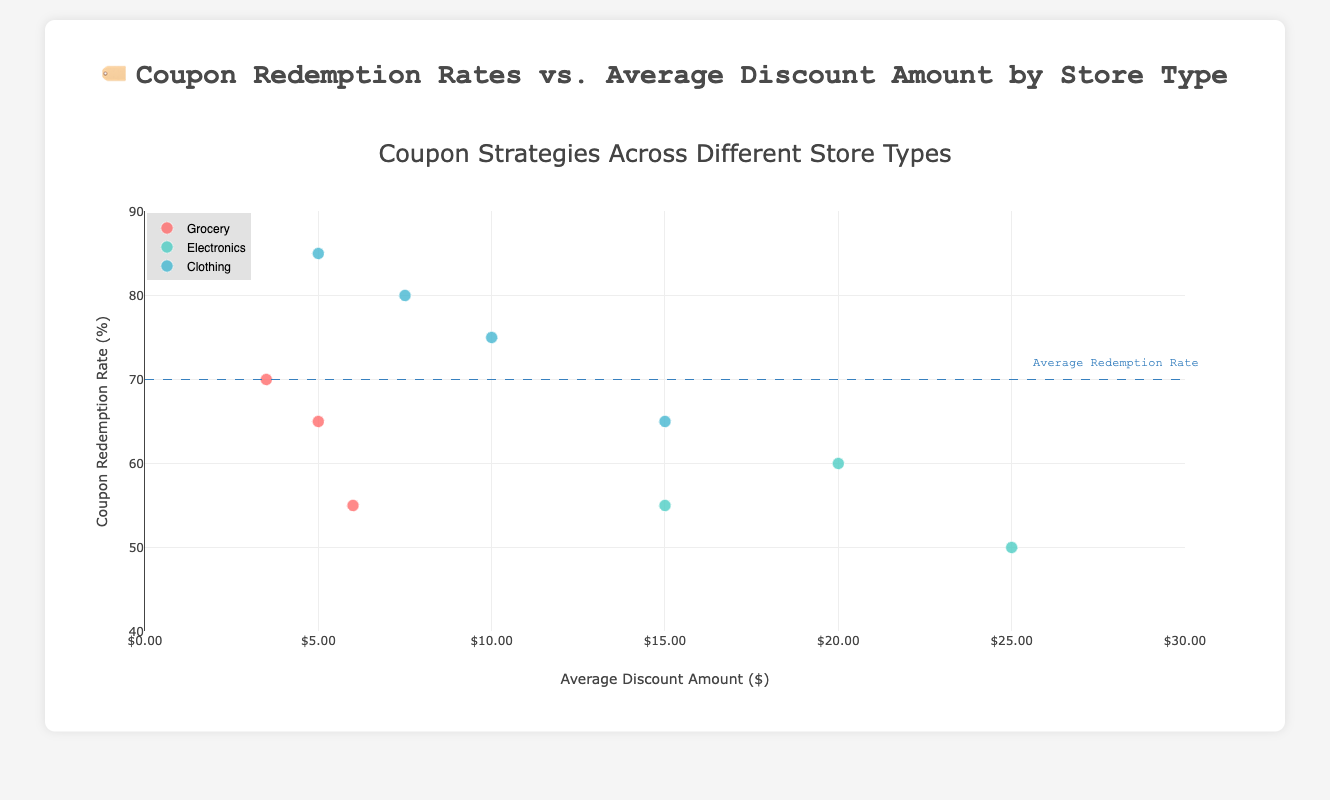What is the title of the scatter plot? The title is displayed at the top of the scatter plot and summarizes what the plot is about. In this case, it provides information on the relationship between coupon redemption rates and average discount amounts by store type.
Answer: Coupon Redemption Rates vs. Average Discount Amount by Store Type How many store types are represented in the scatter plot? Each store type will have a distinct marker color, and there's a legend indicating the store types. By counting these distinct colors or legend entries, we can determine the number of store types.
Answer: 3 Which store type shows the highest coupon redemption rate? By looking at the y-axis (Coupon Redemption Rate (%)) and identifying the data points that are the highest, we can see which store type those points belong to.
Answer: Clothing (H&M at 85%) What is the average discount amount for the store with the lowest coupon redemption rate in the Electronics category? Check the data points in the Electronics category by filtering them and find the one with the lowest value on the y-axis (Coupon Redemption Rate). Then, reference the corresponding x-axis value for the Average Discount Amount.
Answer: $25.00 (Micro Center at 50%) Compare the average discount amounts between the highest coupon redemption rate in the Clothing category and the highest in the Grocery category. Identify the highest coupon redemption rates in both categories by checking their y-axis values and then note their corresponding x-axis values. For Clothing, it's H&M with a $5.00 discount, and for Grocery, it's Kroger with a $3.50 discount.
Answer: Clothing is higher ($5.00 vs $3.50) Which store offers the highest average discount amount, and what is its coupon redemption rate? Identify the data point with the highest x-axis value (Average Discount Amount) and then check its y-axis value for the corresponding Coupon Redemption Rate.
Answer: Micro Center (Average Discount: $25.00, Redemption Rate: 50%) How does the average discount amount for Best Buy compare to that of Nordstrom? Locate the data points for Best Buy and Nordstrom, then compare their x-axis values to see which one is higher or lower.
Answer: Best Buy offers a lower discount ($20.00 vs $15.00) What general trend can you observe about the relationship between average discount amount and coupon redemption rate across all store types? By examining the scatter plot as a whole, observe if there's a pattern, such as whether higher discounts correlate with higher or lower redemption rates, across all store types.
Answer: Higher discounts tend to have lower redemption rates Among the Grocery stores, which one has the highest average discount amount and what is its redemption rate? Look at the Grocery category data points and find the one with the highest x-axis value (Average Discount Amount) and then note its y-axis value (Redemption Rate).
Answer: Whole Foods (Discount: $6.00, Redemption Rate: 55%) What does the dashed horizontal line at 70% indicate, and which stores are above this line? The dashed line represents the average coupon redemption rate of 70%. To find stores above this line, look for data points higher than this line on the y-axis.
Answer: Kroger, Macy's, Gap, and H&M 